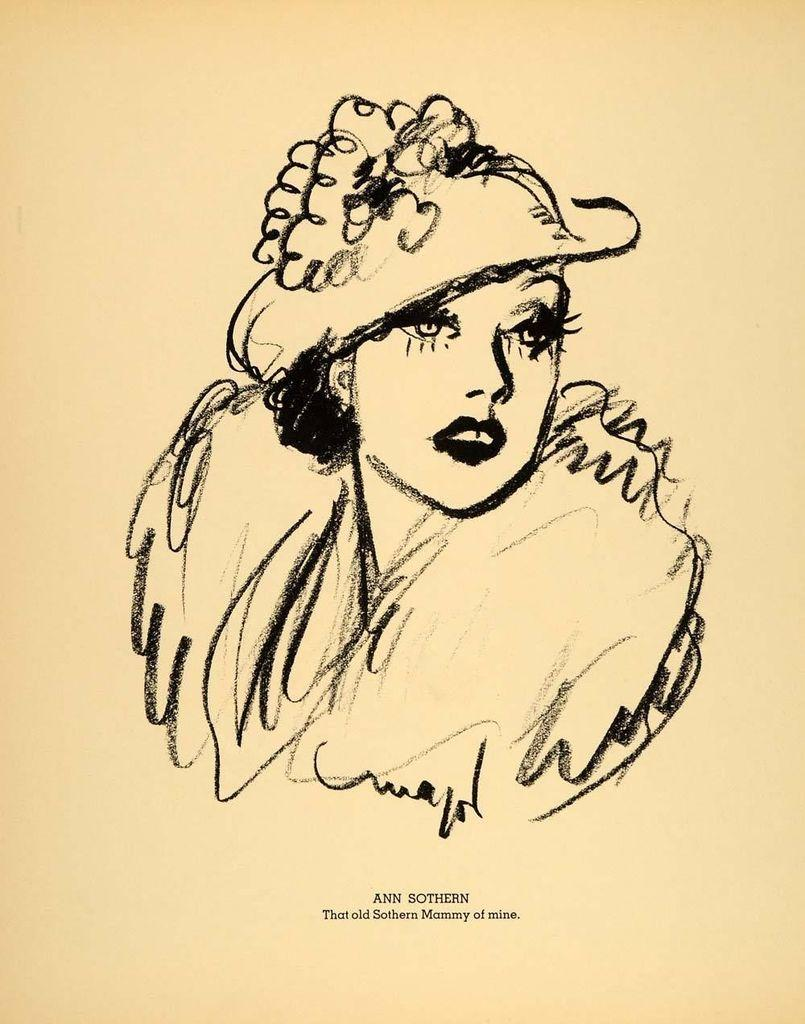What is depicted in the image? The image contains a crayon sketch of a woman. Is there any text associated with the image? Yes, there is text at the bottom of the image. How many sisters does the woman in the sketch have, and are they also depicted in the image? There is no information about the woman's sisters in the image, nor are they depicted. 